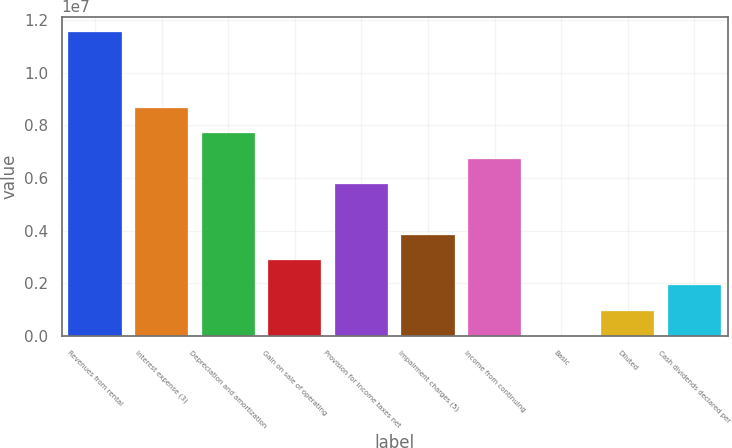Convert chart. <chart><loc_0><loc_0><loc_500><loc_500><bar_chart><fcel>Revenues from rental<fcel>Interest expense (3)<fcel>Depreciation and amortization<fcel>Gain on sale of operating<fcel>Provision for income taxes net<fcel>Impairment charges (5)<fcel>Income from continuing<fcel>Basic<fcel>Diluted<fcel>Cash dividends declared per<nl><fcel>1.15545e+07<fcel>8.66589e+06<fcel>7.70301e+06<fcel>2.88863e+06<fcel>5.77726e+06<fcel>3.8515e+06<fcel>6.74013e+06<fcel>0.1<fcel>962876<fcel>1.92575e+06<nl></chart> 